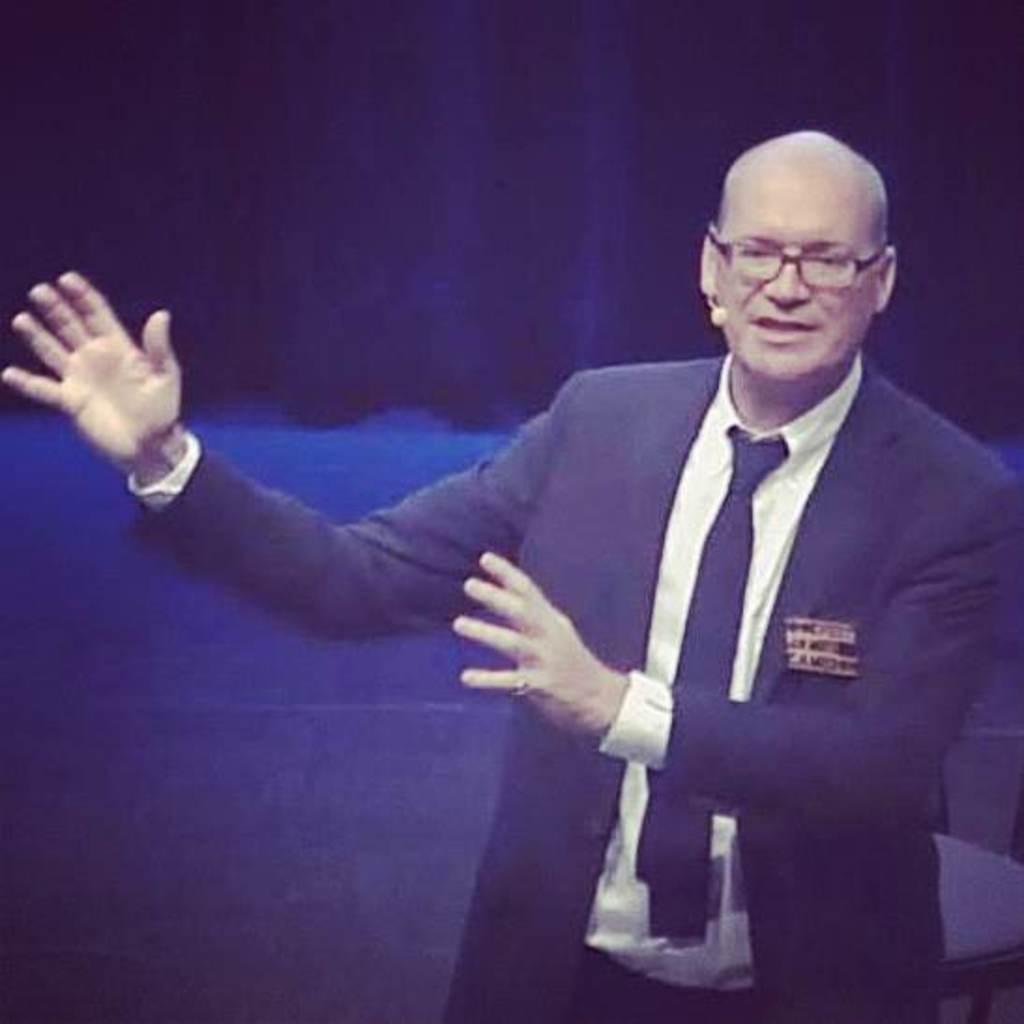In one or two sentences, can you explain what this image depicts? In the picture there is a man he is wearing a blazer and he is explaining something, the man is also wearing spectacles and the background of the man is in blue color. 